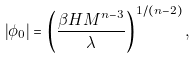Convert formula to latex. <formula><loc_0><loc_0><loc_500><loc_500>\left | \phi _ { 0 } \right | = \left ( \frac { \beta H M ^ { n - 3 } } { \lambda } \right ) ^ { 1 / ( n - 2 ) } ,</formula> 